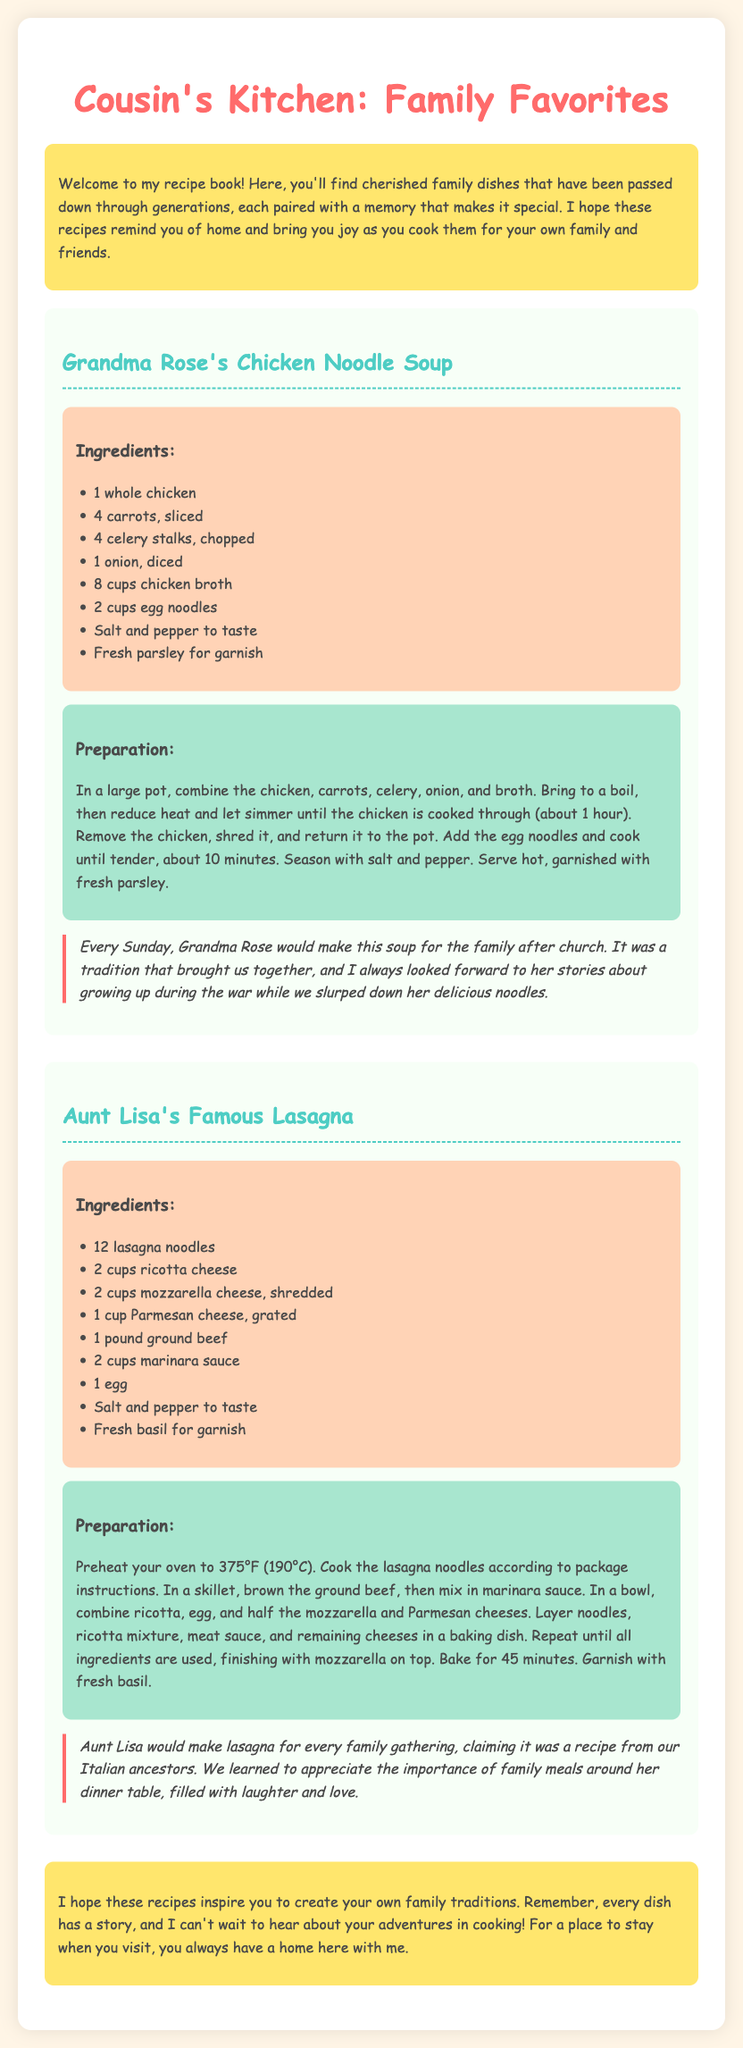What is the title of the recipe book? The title of the recipe book is presented at the top of the document.
Answer: Cousin's Kitchen: Family Favorites Who is the author of the Chicken Noodle Soup recipe? The Chicken Noodle Soup recipe is attributed to a specific family member mentioned in the document.
Answer: Grandma Rose How many cups of chicken broth are needed for the Chicken Noodle Soup? This quantity is stated in the ingredients list for the Chicken Noodle Soup recipe.
Answer: 8 cups What oven temperature is required for Aunt Lisa's Lasagna? The required temperature for baking the lasagna is mentioned in the preparation section of the recipe.
Answer: 375°F (190°C) What is a traditional meal made every Sunday? This information is found in the anecdote associated with the Chicken Noodle Soup recipe.
Answer: Chicken Noodle Soup How many layers are suggested for constructing Aunt Lisa's Lasagna? The preparation details imply multiple layers, but does not specify an exact number.
Answer: Not specified What ingredient is used for garnishing the Chicken Noodle Soup? The recipe for Chicken Noodle Soup lists this garnish in the ingredients section.
Answer: Fresh parsley What was Aunt Lisa's claim about her lasagna recipe? This claim is described in the anecdote that accompanies Aunt Lisa's recipe.
Answer: Recipe from our Italian ancestors 